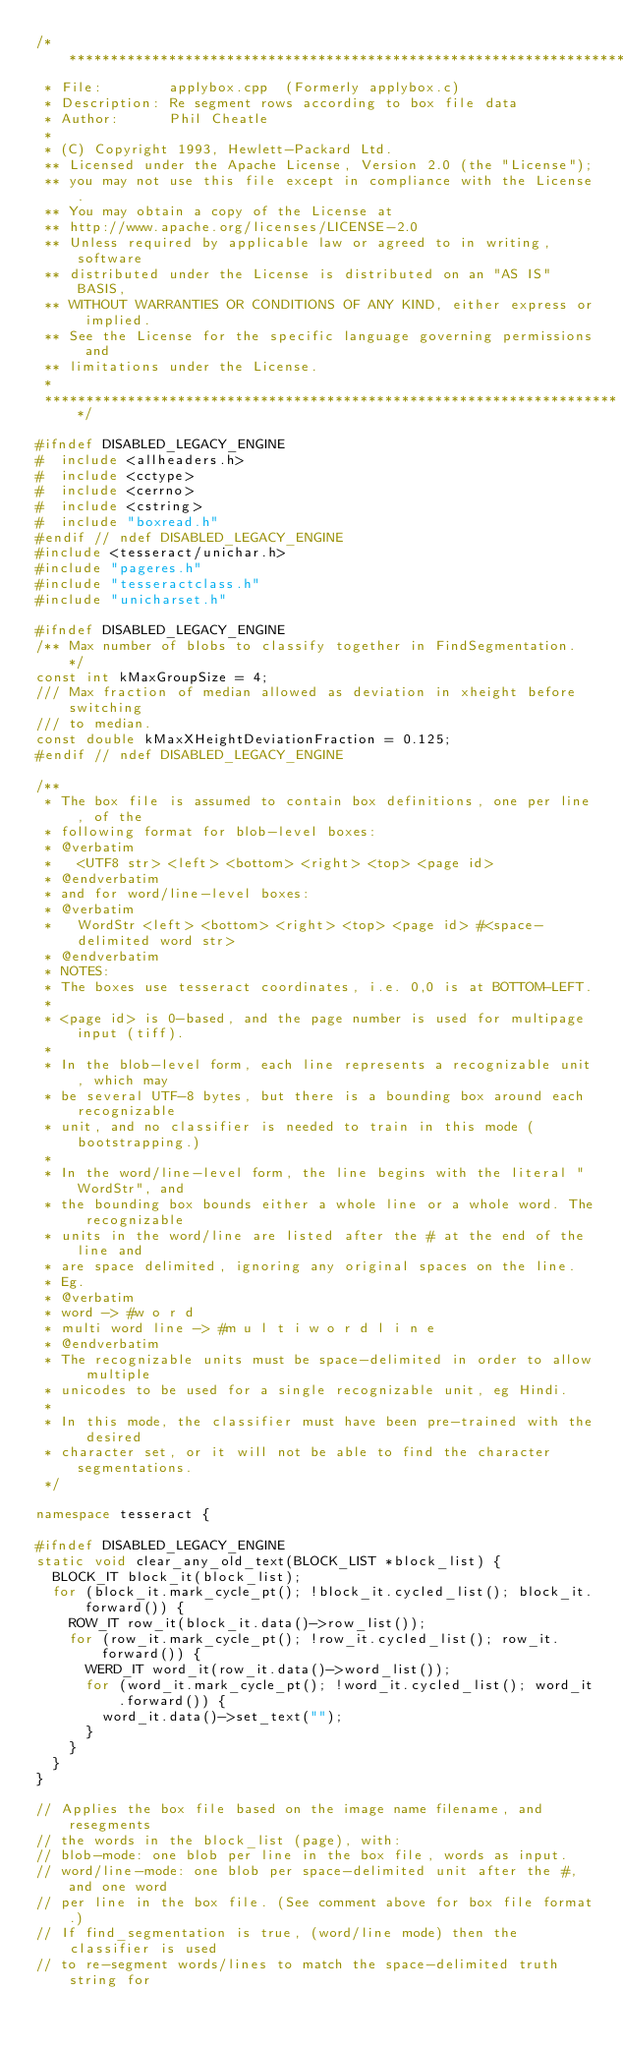Convert code to text. <code><loc_0><loc_0><loc_500><loc_500><_C++_>/**********************************************************************
 * File:        applybox.cpp  (Formerly applybox.c)
 * Description: Re segment rows according to box file data
 * Author:      Phil Cheatle
 *
 * (C) Copyright 1993, Hewlett-Packard Ltd.
 ** Licensed under the Apache License, Version 2.0 (the "License");
 ** you may not use this file except in compliance with the License.
 ** You may obtain a copy of the License at
 ** http://www.apache.org/licenses/LICENSE-2.0
 ** Unless required by applicable law or agreed to in writing, software
 ** distributed under the License is distributed on an "AS IS" BASIS,
 ** WITHOUT WARRANTIES OR CONDITIONS OF ANY KIND, either express or implied.
 ** See the License for the specific language governing permissions and
 ** limitations under the License.
 *
 **********************************************************************/

#ifndef DISABLED_LEGACY_ENGINE
#  include <allheaders.h>
#  include <cctype>
#  include <cerrno>
#  include <cstring>
#  include "boxread.h"
#endif // ndef DISABLED_LEGACY_ENGINE
#include <tesseract/unichar.h>
#include "pageres.h"
#include "tesseractclass.h"
#include "unicharset.h"

#ifndef DISABLED_LEGACY_ENGINE
/** Max number of blobs to classify together in FindSegmentation. */
const int kMaxGroupSize = 4;
/// Max fraction of median allowed as deviation in xheight before switching
/// to median.
const double kMaxXHeightDeviationFraction = 0.125;
#endif // ndef DISABLED_LEGACY_ENGINE

/**
 * The box file is assumed to contain box definitions, one per line, of the
 * following format for blob-level boxes:
 * @verbatim
 *   <UTF8 str> <left> <bottom> <right> <top> <page id>
 * @endverbatim
 * and for word/line-level boxes:
 * @verbatim
 *   WordStr <left> <bottom> <right> <top> <page id> #<space-delimited word str>
 * @endverbatim
 * NOTES:
 * The boxes use tesseract coordinates, i.e. 0,0 is at BOTTOM-LEFT.
 *
 * <page id> is 0-based, and the page number is used for multipage input (tiff).
 *
 * In the blob-level form, each line represents a recognizable unit, which may
 * be several UTF-8 bytes, but there is a bounding box around each recognizable
 * unit, and no classifier is needed to train in this mode (bootstrapping.)
 *
 * In the word/line-level form, the line begins with the literal "WordStr", and
 * the bounding box bounds either a whole line or a whole word. The recognizable
 * units in the word/line are listed after the # at the end of the line and
 * are space delimited, ignoring any original spaces on the line.
 * Eg.
 * @verbatim
 * word -> #w o r d
 * multi word line -> #m u l t i w o r d l i n e
 * @endverbatim
 * The recognizable units must be space-delimited in order to allow multiple
 * unicodes to be used for a single recognizable unit, eg Hindi.
 *
 * In this mode, the classifier must have been pre-trained with the desired
 * character set, or it will not be able to find the character segmentations.
 */

namespace tesseract {

#ifndef DISABLED_LEGACY_ENGINE
static void clear_any_old_text(BLOCK_LIST *block_list) {
  BLOCK_IT block_it(block_list);
  for (block_it.mark_cycle_pt(); !block_it.cycled_list(); block_it.forward()) {
    ROW_IT row_it(block_it.data()->row_list());
    for (row_it.mark_cycle_pt(); !row_it.cycled_list(); row_it.forward()) {
      WERD_IT word_it(row_it.data()->word_list());
      for (word_it.mark_cycle_pt(); !word_it.cycled_list(); word_it.forward()) {
        word_it.data()->set_text("");
      }
    }
  }
}

// Applies the box file based on the image name filename, and resegments
// the words in the block_list (page), with:
// blob-mode: one blob per line in the box file, words as input.
// word/line-mode: one blob per space-delimited unit after the #, and one word
// per line in the box file. (See comment above for box file format.)
// If find_segmentation is true, (word/line mode) then the classifier is used
// to re-segment words/lines to match the space-delimited truth string for</code> 